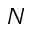Convert formula to latex. <formula><loc_0><loc_0><loc_500><loc_500>N</formula> 